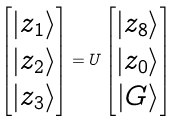Convert formula to latex. <formula><loc_0><loc_0><loc_500><loc_500>\begin{bmatrix} | z _ { 1 } \rangle \\ | z _ { 2 } \rangle \\ | z _ { 3 } \rangle \\ \end{bmatrix} = U \begin{bmatrix} | z _ { 8 } \rangle \\ | z _ { 0 } \rangle \\ | G \rangle \\ \end{bmatrix}</formula> 